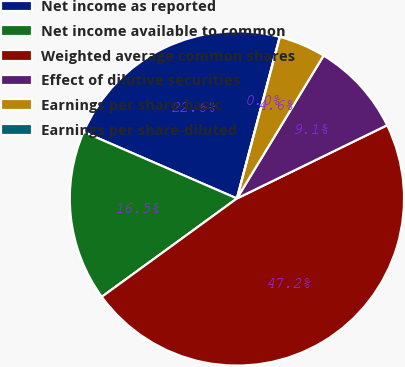Convert chart. <chart><loc_0><loc_0><loc_500><loc_500><pie_chart><fcel>Net income as reported<fcel>Net income available to common<fcel>Weighted average common shares<fcel>Effect of dilutive securities<fcel>Earnings per share-basic<fcel>Earnings per share-diluted<nl><fcel>22.61%<fcel>16.53%<fcel>47.21%<fcel>9.1%<fcel>4.55%<fcel>0.0%<nl></chart> 